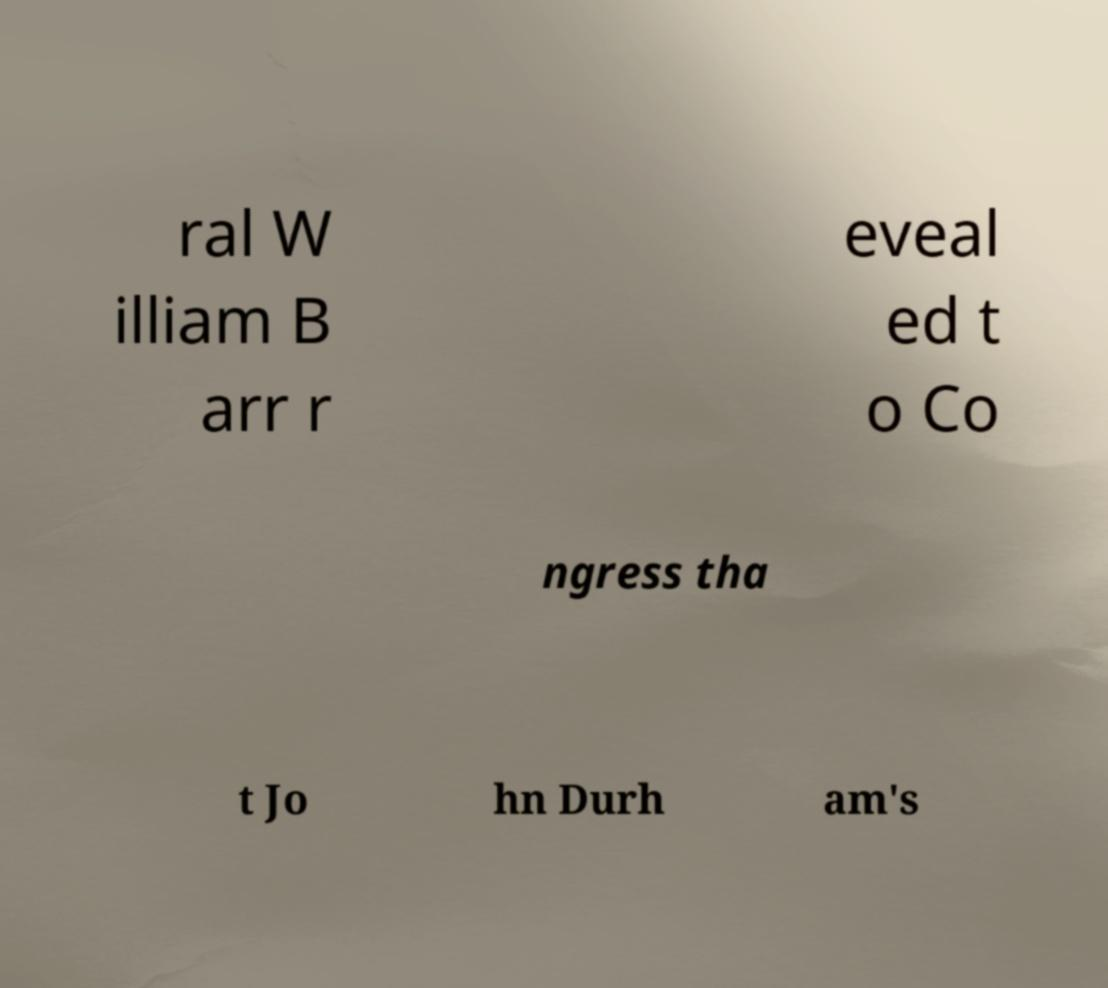Can you read and provide the text displayed in the image?This photo seems to have some interesting text. Can you extract and type it out for me? ral W illiam B arr r eveal ed t o Co ngress tha t Jo hn Durh am's 